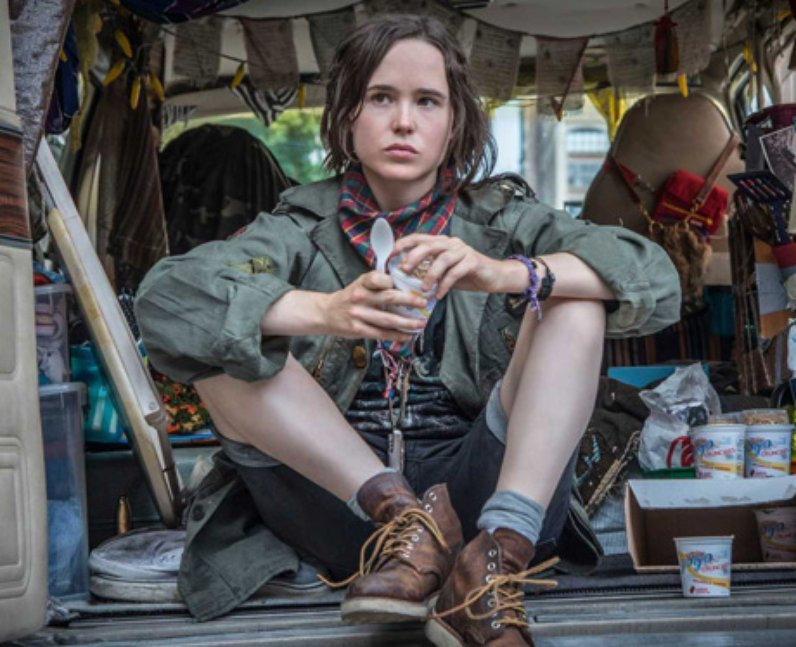What emotions or thoughts might the expression on Elliot’s face convey in this moment? Elliot Page's expression, which is serious and introspective, likely portrays a moment of deep thought or concern. This could be reflecting on personal matters or delving into a complex character’s emotions and motivations within a professional project, suggesting an intersection of personal and professional reflection. Given the clutter and the choice of clothing, what might this scene suggest about the character's lifestyle or profession? This scene, with its practical clothing and chaotic surroundings, suggests a character who is possibly adventurous or nomadic, someone used to living out of a van and constantly on the move, perhaps involved in outdoor activities or fieldwork. The clutter indicates a makeshift living arrangement that doubles as a workspace, pointing to a lifestyle that values flexibility, freedom, and functionality over comfort or stability. 